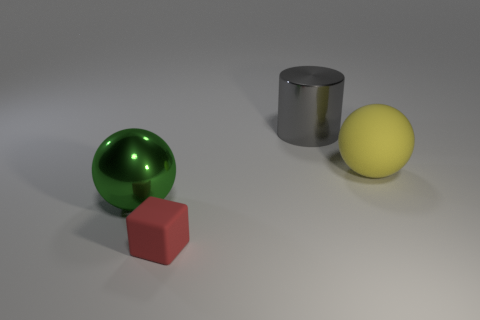How does the texture of the green sphere compare to the other objects? The green sphere has a highly reflective, shiny texture, which contrasts with the matte surface of the red cube and the slightly less reflective metallic cylinder. 